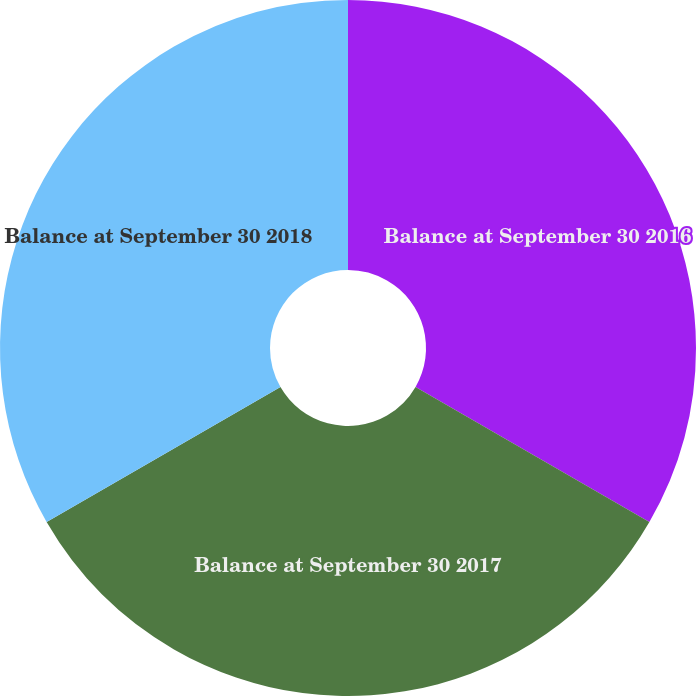Convert chart to OTSL. <chart><loc_0><loc_0><loc_500><loc_500><pie_chart><fcel>Balance at September 30 2016<fcel>Balance at September 30 2017<fcel>Balance at September 30 2018<nl><fcel>33.33%<fcel>33.33%<fcel>33.33%<nl></chart> 